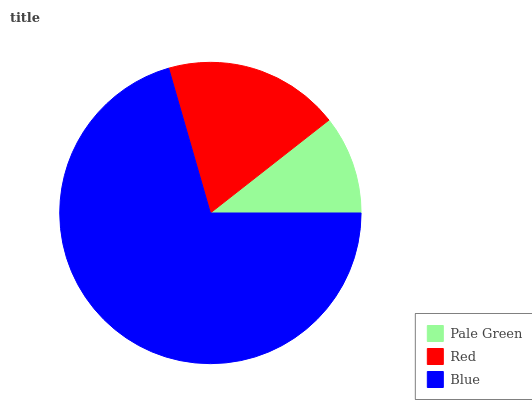Is Pale Green the minimum?
Answer yes or no. Yes. Is Blue the maximum?
Answer yes or no. Yes. Is Red the minimum?
Answer yes or no. No. Is Red the maximum?
Answer yes or no. No. Is Red greater than Pale Green?
Answer yes or no. Yes. Is Pale Green less than Red?
Answer yes or no. Yes. Is Pale Green greater than Red?
Answer yes or no. No. Is Red less than Pale Green?
Answer yes or no. No. Is Red the high median?
Answer yes or no. Yes. Is Red the low median?
Answer yes or no. Yes. Is Pale Green the high median?
Answer yes or no. No. Is Blue the low median?
Answer yes or no. No. 